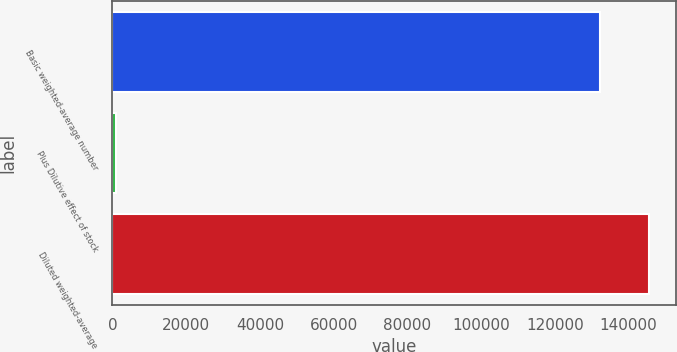Convert chart to OTSL. <chart><loc_0><loc_0><loc_500><loc_500><bar_chart><fcel>Basic weighted-average number<fcel>Plus Dilutive effect of stock<fcel>Diluted weighted-average<nl><fcel>132284<fcel>883<fcel>145512<nl></chart> 